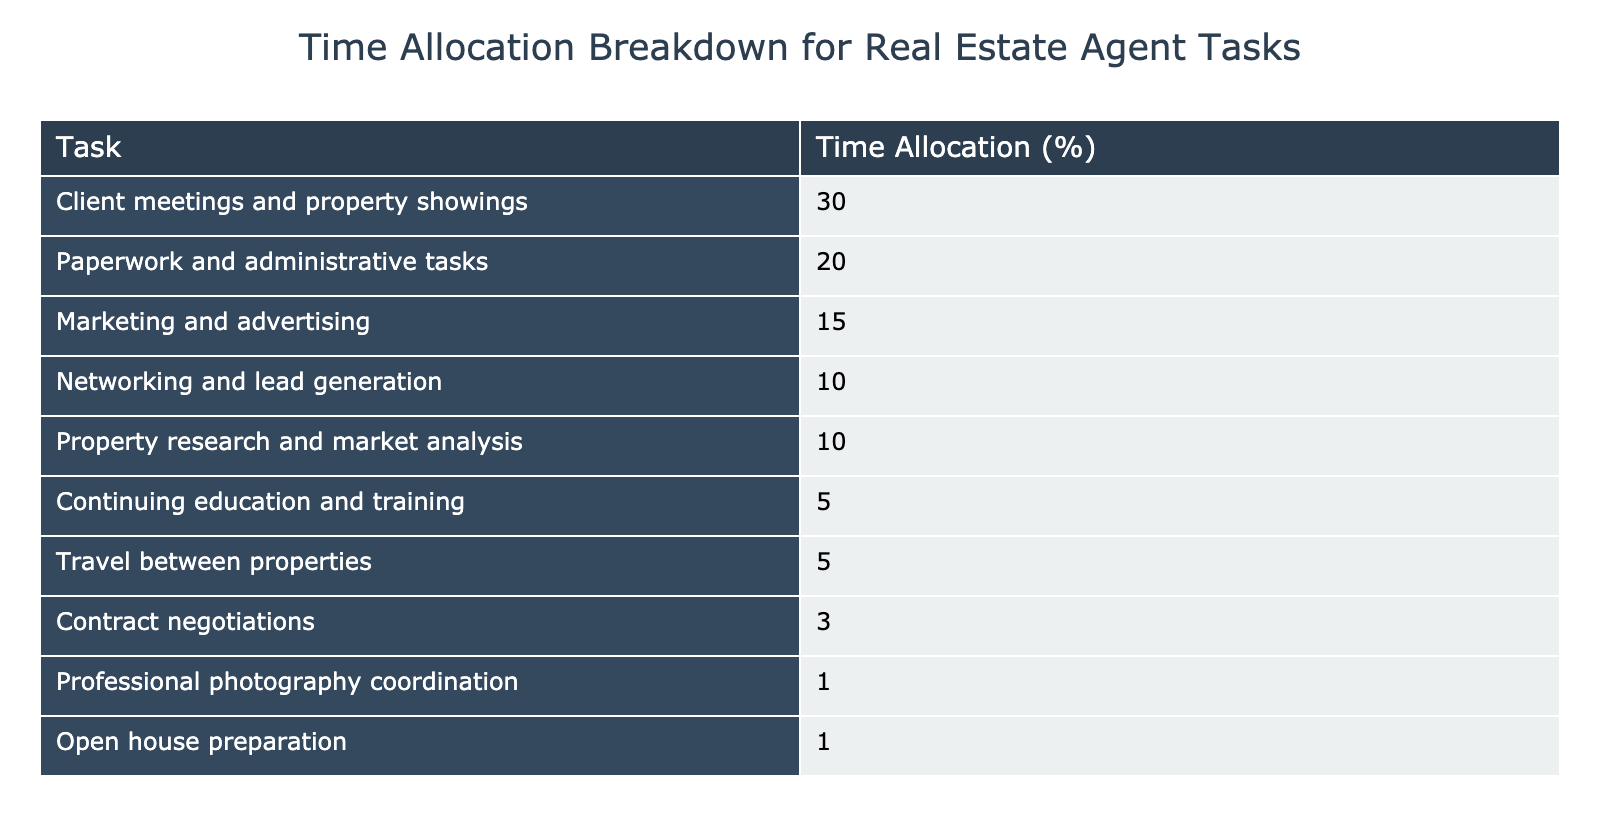What is the highest percentage of time allocated to a single task? The table shows various tasks along with their percentage allocations. The highest value listed is for client meetings and property showings, which is 30%.
Answer: 30% What percentage of time is spent on paperwork and administrative tasks combined with travel between properties? The time allocation for paperwork and administrative tasks is 20%, while the allocation for travel between properties is 5%. Adding these together gives 20% + 5% = 25%.
Answer: 25% Is the time allocated to continuing education and training greater than that for contract negotiations? The table indicates that continuing education and training is 5%, and contract negotiations is 3%. Since 5% is greater than 3%, the statement is true.
Answer: Yes What percentage represents the total time spent on marketing and advertising compared to networking and lead generation? Marketing and advertising accounts for 15% of the time, while networking and lead generation accounts for 10%. Therefore, when compared, we can see that marketing and advertising (15%) is greater than networking and lead generation (10%).
Answer: 15% is greater than 10% What is the combined percentage of time spent on tasks related to client management (client meetings, open houses) versus administrative tasks (paperwork, negotiations)? The total for client management includes client meetings (30%) and open house preparation (1%), summing to 31%. For administrative tasks, paperwork is at 20% and contract negotiations at 3%, summing to 23%. Comparing the two: 31% (client management) is greater than 23% (administrative tasks).
Answer: 31% is greater than 23% 